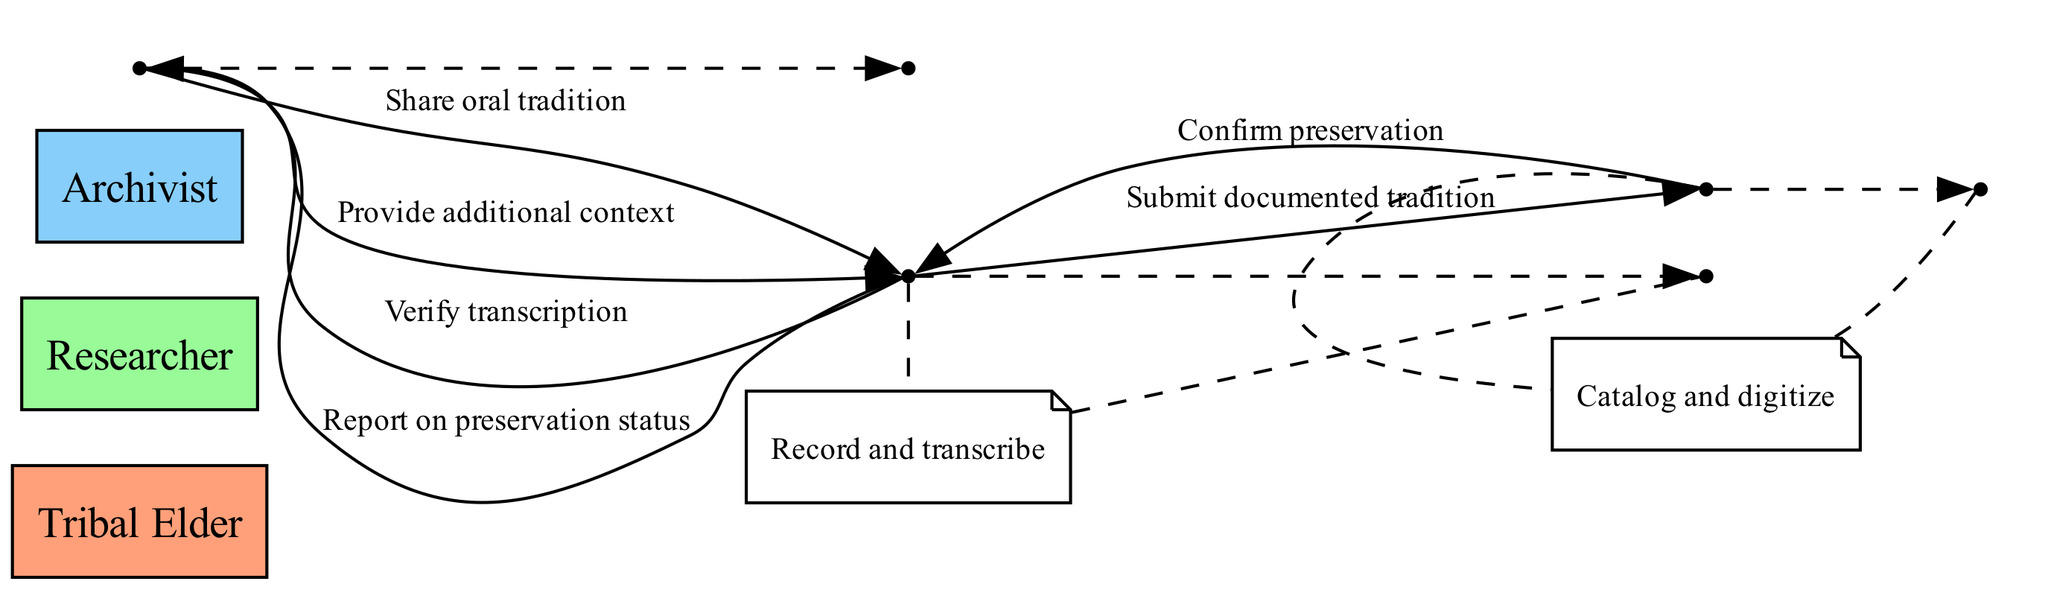What is the first action taken in the sequence diagram? The sequence begins with the Tribal Elder sharing an oral tradition with the Researcher. This is the first interaction depicted in the sequence.
Answer: Share oral tradition How many actors are involved in the process? The diagram includes three distinct actors: Tribal Elder, Researcher, and Archivist. Each actor participates in different steps throughout the process.
Answer: Three What action does the Researcher take after recording and transcribing? After recording and transcribing, the Researcher verifies the transcription with the Tribal Elder to ensure accuracy and completeness.
Answer: Verify transcription Which actor confirms the preservation of the documented tradition? The Archivist is responsible for confirming the preservation of the documented tradition once it has been cataloged and digitized.
Answer: Archivist What does the Tribal Elder provide after verifying the transcription? The Tribal Elder provides additional context to the Researcher, enhancing the understanding of the oral tradition. This step follows the verification of transcription.
Answer: Provide additional context Which two actors are involved when the Researcher submits the documented tradition? The Researcher submits the documented tradition to the Archivist, creating a handoff at this stage of the process. This is a direct interaction between the two individuals.
Answer: Researcher and Archivist How many actions are self-initiated by the Archivist? The Archivist has a self-loop in the sequence diagram where they catalog and digitize the tradition, indicating this action is done internally.
Answer: One Which actor is involved last in the sequence when reporting the preservation status? The Researcher is the last actor to engage in the sequence, as they report on the preservation status to the Tribal Elder, completing the flow of interaction.
Answer: Researcher 